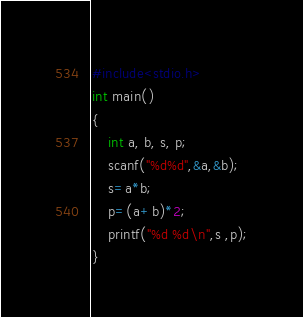Convert code to text. <code><loc_0><loc_0><loc_500><loc_500><_C_>#include<stdio.h>
int main()
{
    int a, b, s, p;
    scanf("%d%d",&a,&b);
    s=a*b;
    p=(a+b)*2;
    printf("%d %d\n",s ,p);
}
</code> 